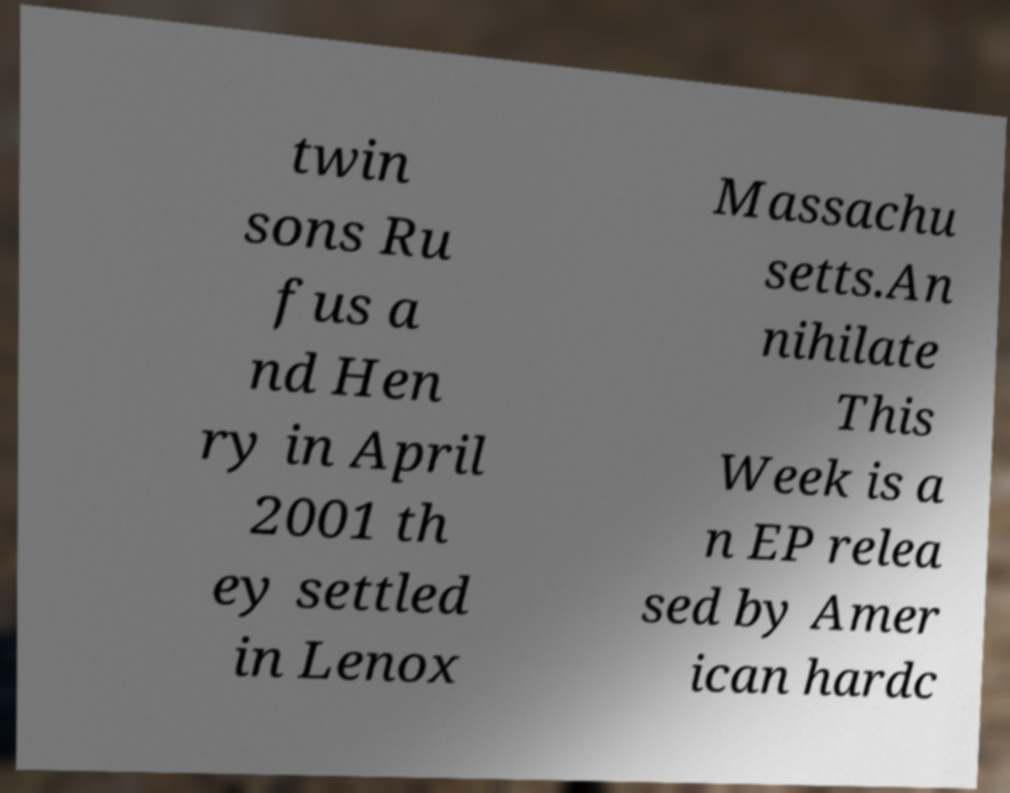Please read and relay the text visible in this image. What does it say? twin sons Ru fus a nd Hen ry in April 2001 th ey settled in Lenox Massachu setts.An nihilate This Week is a n EP relea sed by Amer ican hardc 